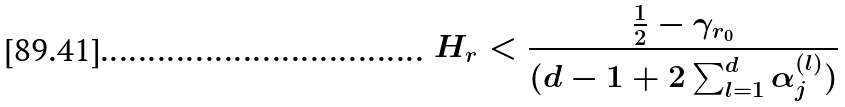<formula> <loc_0><loc_0><loc_500><loc_500>H _ { r } < \frac { \frac { 1 } { 2 } - \gamma _ { r _ { 0 } } } { ( d - 1 + 2 \sum _ { l = 1 } ^ { d } \alpha _ { j } ^ { ( l ) } ) }</formula> 